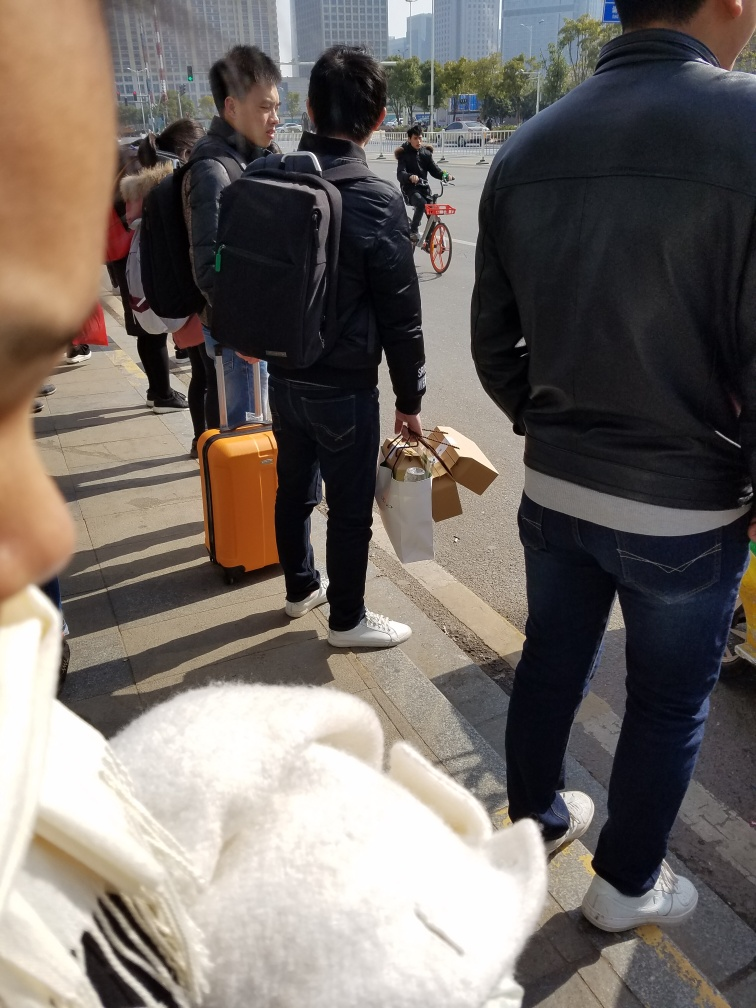How busy does this location seem? The location appears moderately busy, with several individuals standing and walking around, which suggests a public area with steady pedestrian traffic. 